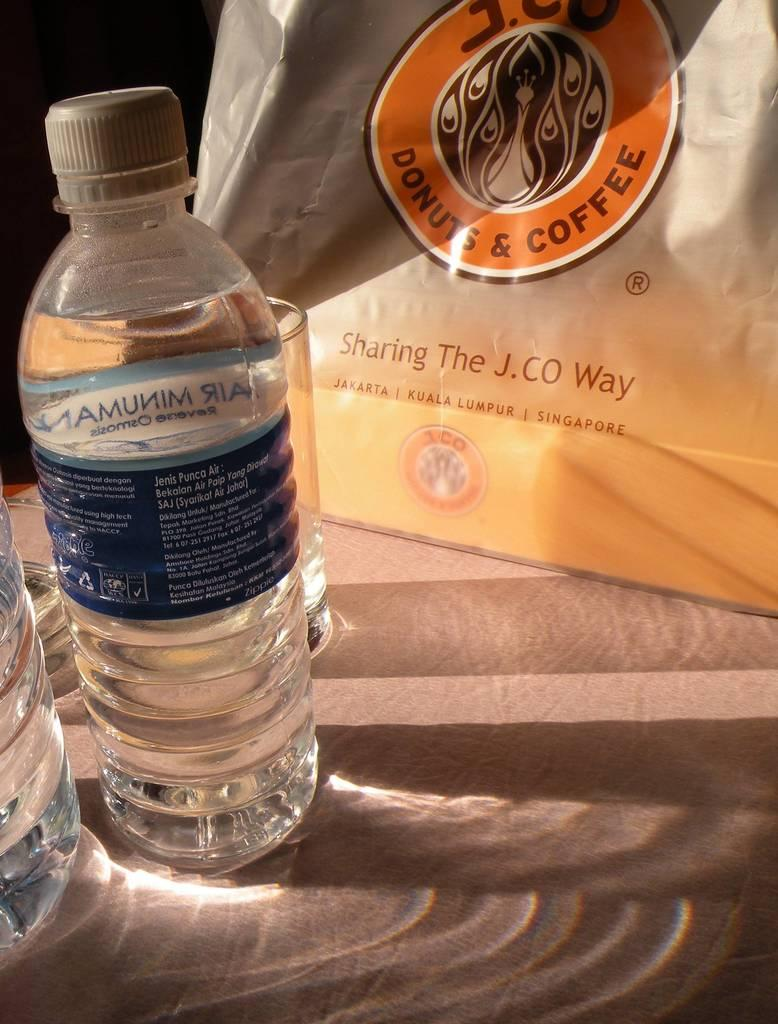What type of containers can be seen in the image? There are bottles and a glass in the image. Where are the glass and bottles located in the image? The glass and bottles are on the left side of the image. What else is present in the image besides the glass and bottles? There is a plastic cover in the image. On which side of the image is the plastic cover located? The plastic cover is on the right side of the image. What type of appliance can be seen in the image? There is no appliance present in the image. Can you see a toad in the image? There is no toad present in the image. 